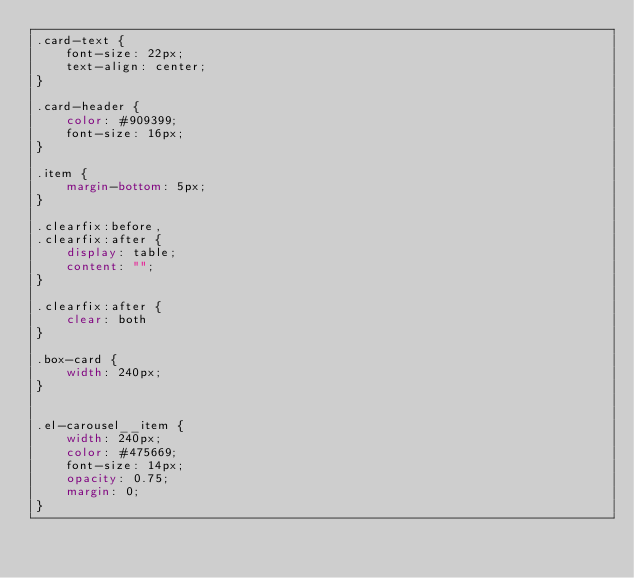<code> <loc_0><loc_0><loc_500><loc_500><_CSS_>.card-text {
    font-size: 22px;
    text-align: center;
}

.card-header {
    color: #909399;
    font-size: 16px;
}

.item {
    margin-bottom: 5px;
}

.clearfix:before,
.clearfix:after {
    display: table;
    content: "";
}

.clearfix:after {
    clear: both
}

.box-card {
    width: 240px;
}


.el-carousel__item {
    width: 240px;
    color: #475669;
    font-size: 14px;
    opacity: 0.75;
    margin: 0;
}
</code> 